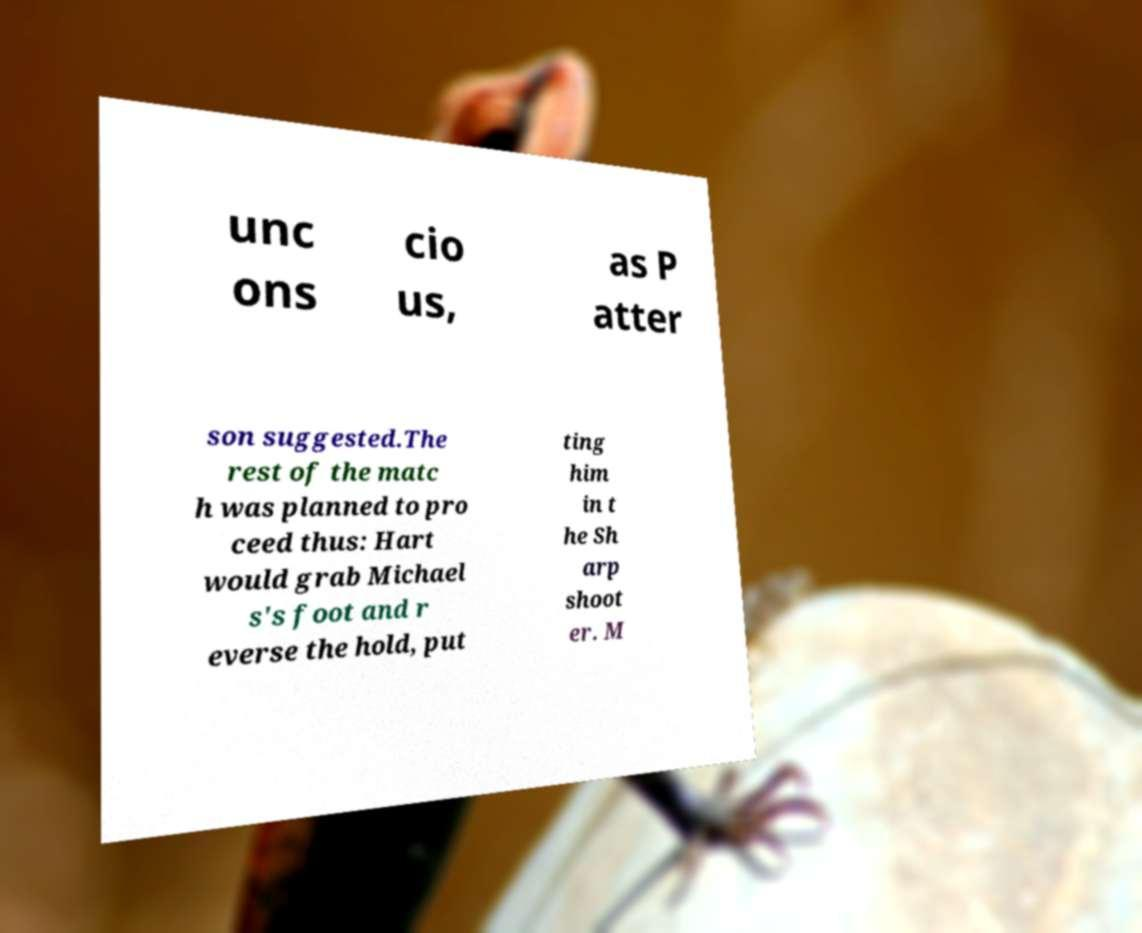I need the written content from this picture converted into text. Can you do that? unc ons cio us, as P atter son suggested.The rest of the matc h was planned to pro ceed thus: Hart would grab Michael s's foot and r everse the hold, put ting him in t he Sh arp shoot er. M 